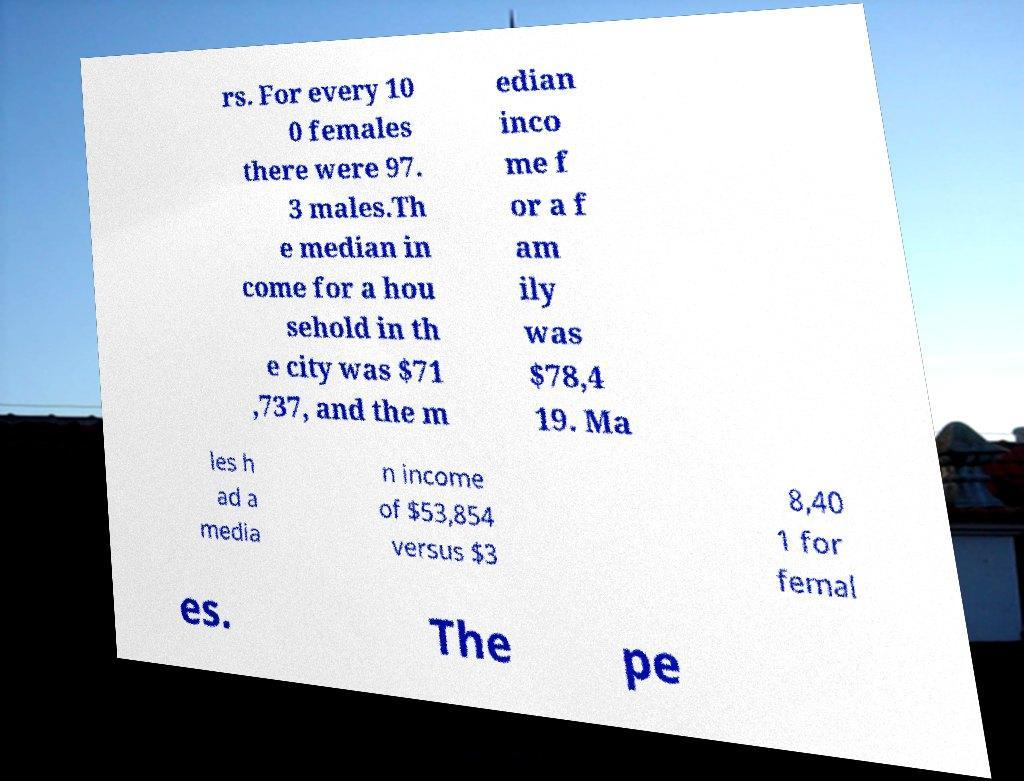I need the written content from this picture converted into text. Can you do that? rs. For every 10 0 females there were 97. 3 males.Th e median in come for a hou sehold in th e city was $71 ,737, and the m edian inco me f or a f am ily was $78,4 19. Ma les h ad a media n income of $53,854 versus $3 8,40 1 for femal es. The pe 